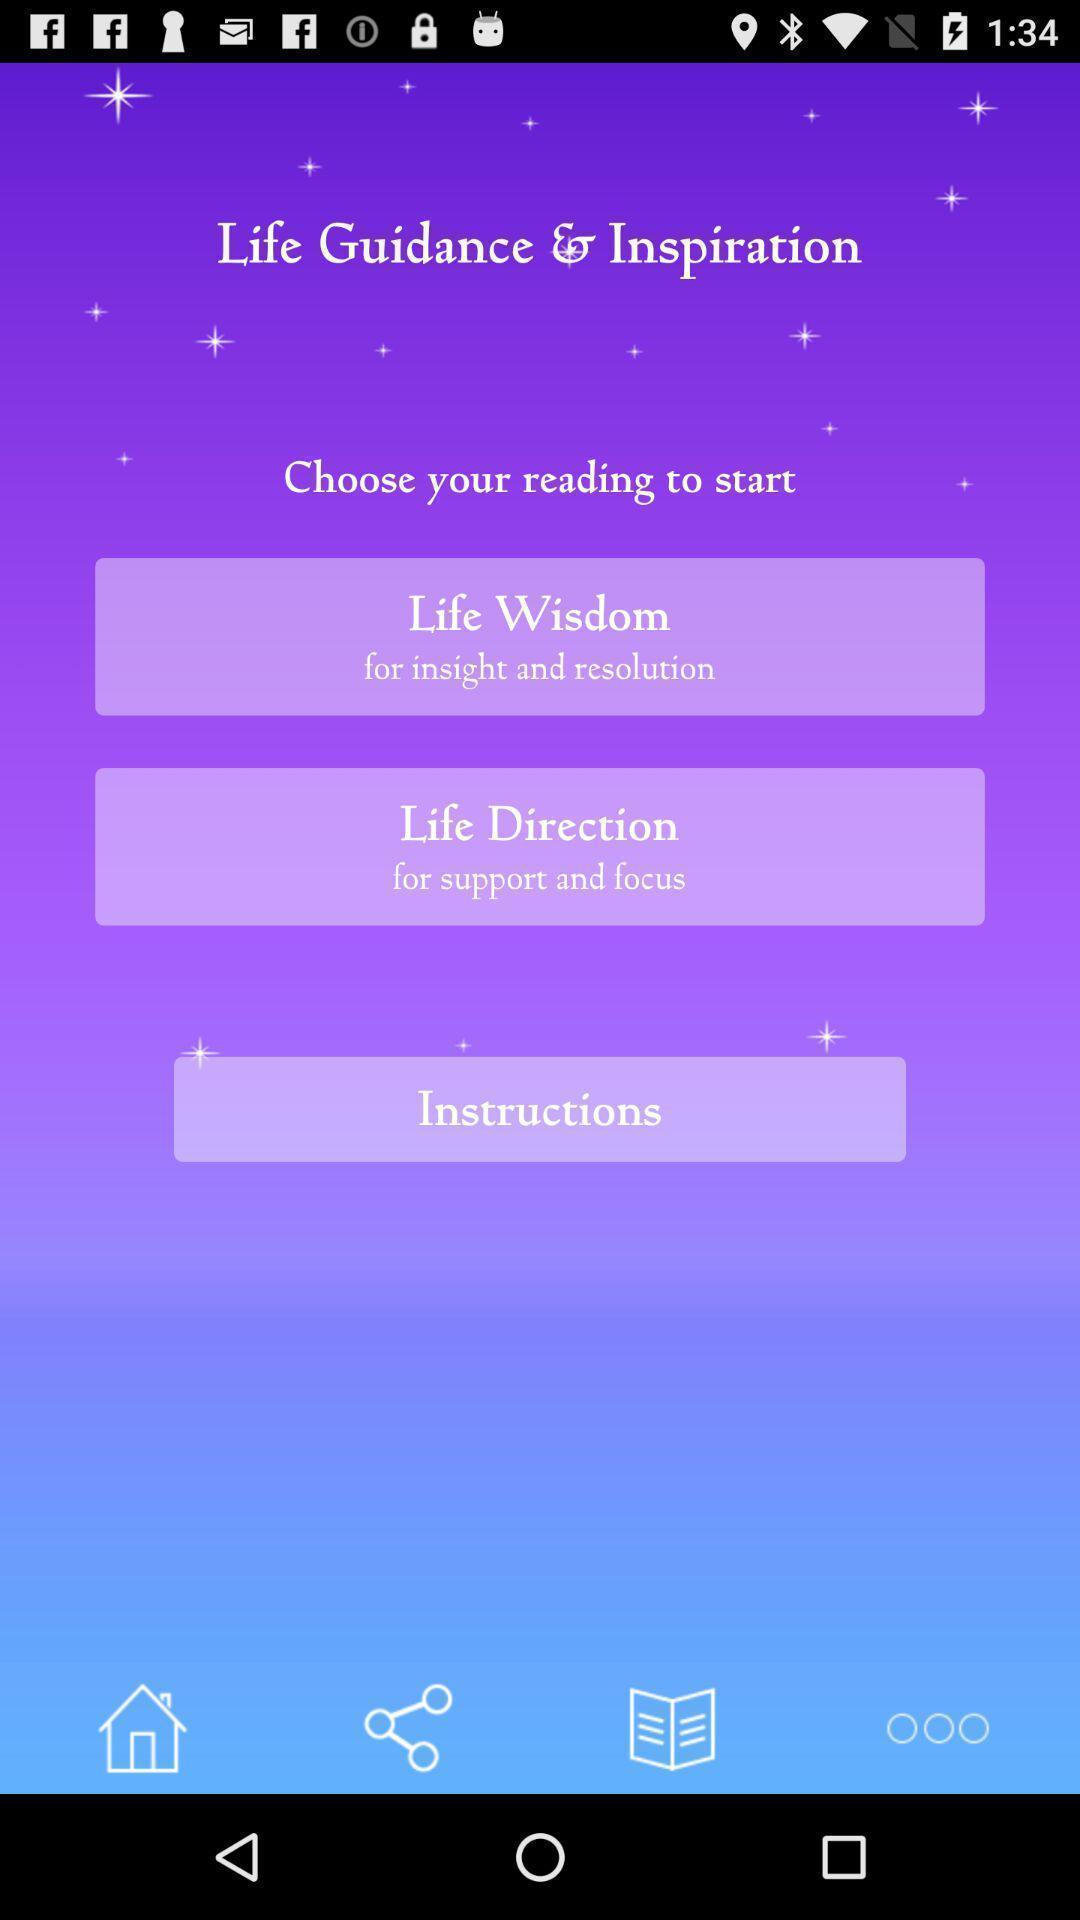What details can you identify in this image? Welcome page for a self development app. 